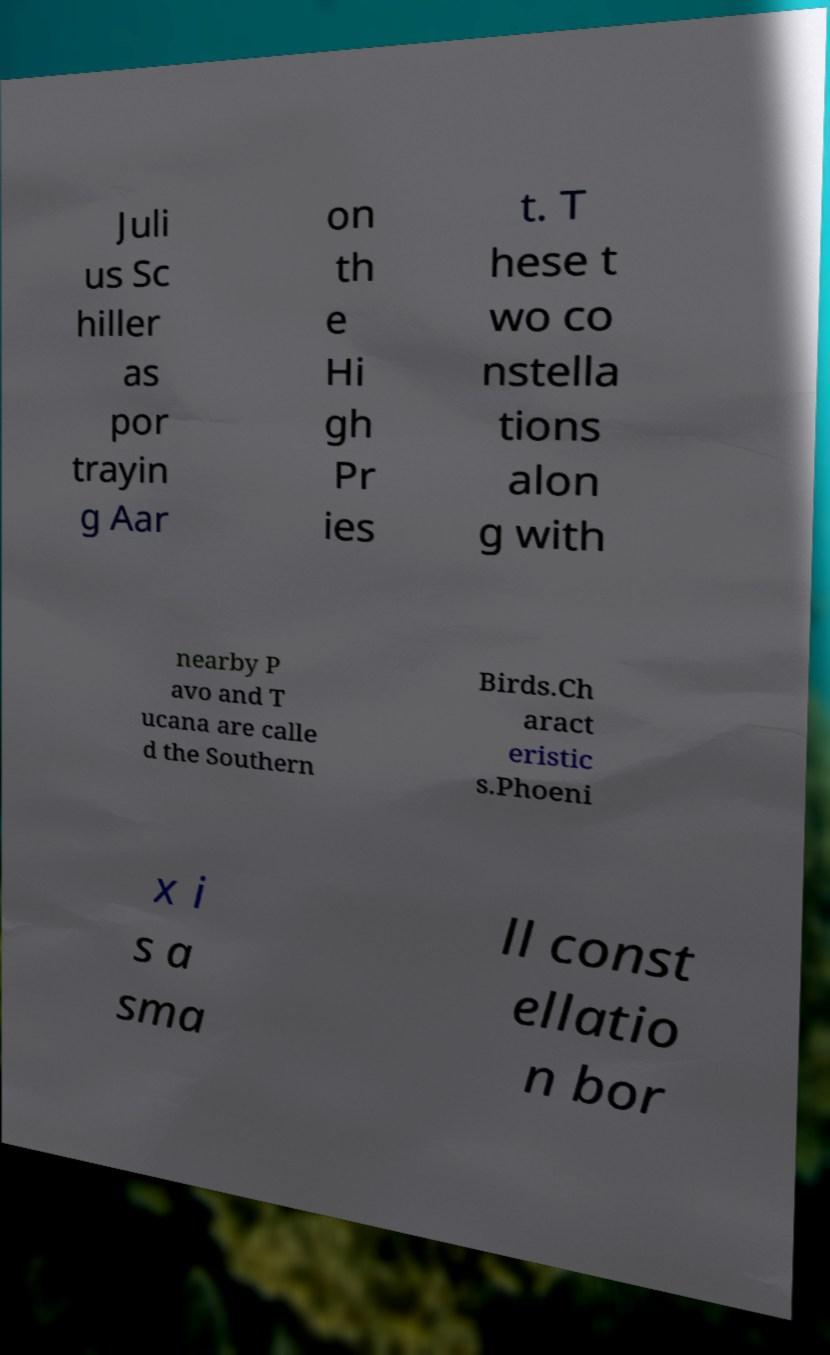Could you extract and type out the text from this image? Juli us Sc hiller as por trayin g Aar on th e Hi gh Pr ies t. T hese t wo co nstella tions alon g with nearby P avo and T ucana are calle d the Southern Birds.Ch aract eristic s.Phoeni x i s a sma ll const ellatio n bor 